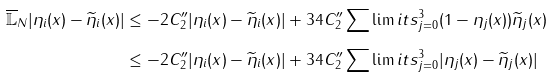<formula> <loc_0><loc_0><loc_500><loc_500>\overline { \mathbb { L } } _ { N } | \eta _ { i } ( x ) - \widetilde { \eta } _ { i } ( x ) | & \leq - 2 C ^ { \prime \prime } _ { 2 } | \eta _ { i } ( x ) - \widetilde { \eta } _ { i } ( x ) | + 3 4 C ^ { \prime \prime } _ { 2 } \sum \lim i t s _ { j = 0 } ^ { 3 } ( 1 - \eta _ { j } ( x ) ) \widetilde { \eta } _ { j } ( x ) \\ & \leq - 2 C ^ { \prime \prime } _ { 2 } | \eta _ { i } ( x ) - \widetilde { \eta } _ { i } ( x ) | + 3 4 C ^ { \prime \prime } _ { 2 } \sum \lim i t s _ { j = 0 } ^ { 3 } | \eta _ { j } ( x ) - \widetilde { \eta } _ { j } ( x ) |</formula> 